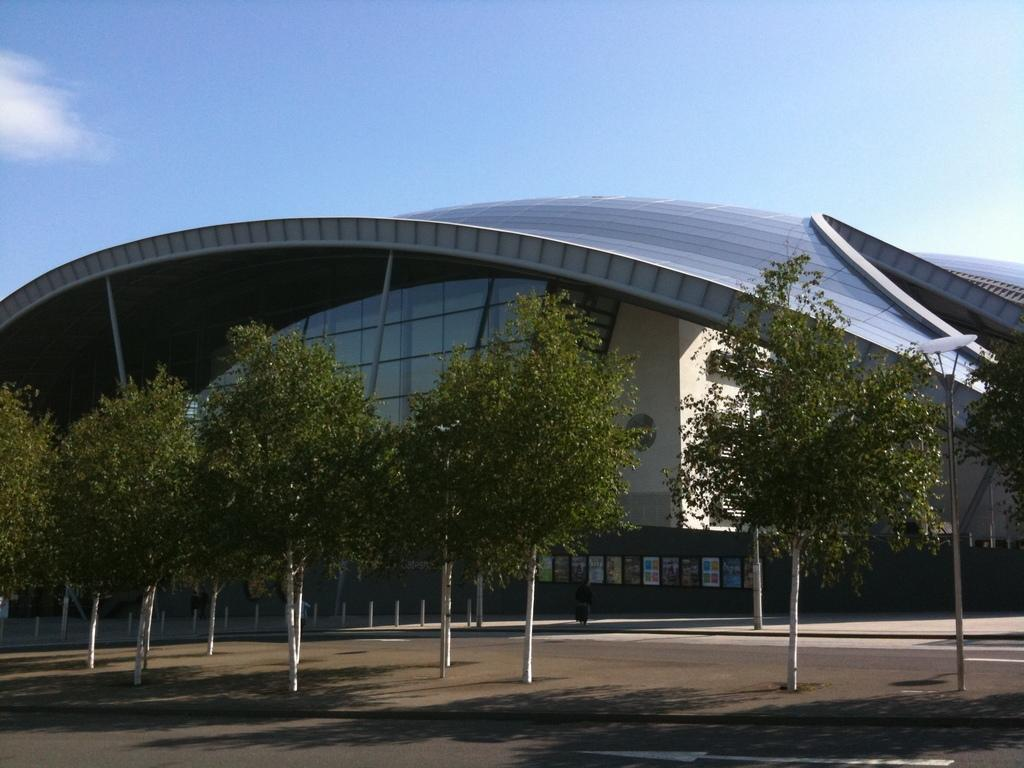What structure can be seen in the image? There is a light pole in the image. What type of man-made structure is also present? There is a building in the image. What objects are made of wood in the image? There are boards in the image. Can you describe the person in the image? There is a person in the image. What type of natural elements are present in the image? There are trees in the image. What part of the natural environment is visible in the image? The sky is visible in the image. What type of plantation can be seen in the image? There is no plantation present in the image. What type of pickle is being used to decorate the building in the image? There is no pickle present in the image. 